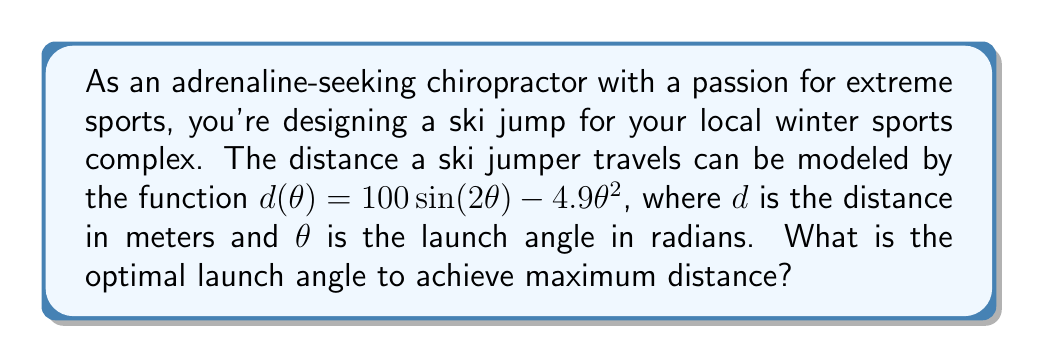Provide a solution to this math problem. To find the optimal angle for maximum distance, we need to find the maximum of the function $d(\theta)$. This can be done by finding where the derivative of $d(\theta)$ equals zero.

Step 1: Calculate the derivative of $d(\theta)$
$$d'(\theta) = 200 \cos(2\theta) - 9.8\theta$$

Step 2: Set the derivative equal to zero and solve for $\theta$
$$200 \cos(2\theta) - 9.8\theta = 0$$

Step 3: This equation cannot be solved algebraically, so we need to use numerical methods. Using a graphing calculator or computer software, we can find that the solution is approximately:

$$\theta \approx 0.6435 \text{ radians}$$

Step 4: Convert radians to degrees
$$0.6435 \text{ radians} \times \frac{180^\circ}{\pi} \approx 36.87^\circ$$

Step 5: Verify this is a maximum by checking the second derivative is negative at this point
$$d''(\theta) = -400 \sin(2\theta) - 9.8$$
$$d''(0.6435) \approx -400 \sin(1.287) - 9.8 \approx -389.8 < 0$$

Therefore, the optimal launch angle for maximum distance is approximately 36.87°.
Answer: 36.87° 